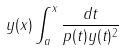Convert formula to latex. <formula><loc_0><loc_0><loc_500><loc_500>y ( x ) \int _ { a } ^ { x } \frac { d t } { p ( t ) y ( t ) ^ { 2 } }</formula> 